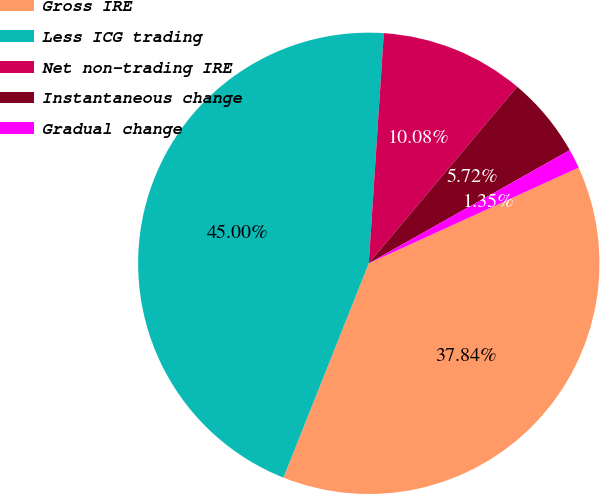Convert chart to OTSL. <chart><loc_0><loc_0><loc_500><loc_500><pie_chart><fcel>Gross IRE<fcel>Less ICG trading<fcel>Net non-trading IRE<fcel>Instantaneous change<fcel>Gradual change<nl><fcel>37.84%<fcel>45.0%<fcel>10.08%<fcel>5.72%<fcel>1.35%<nl></chart> 